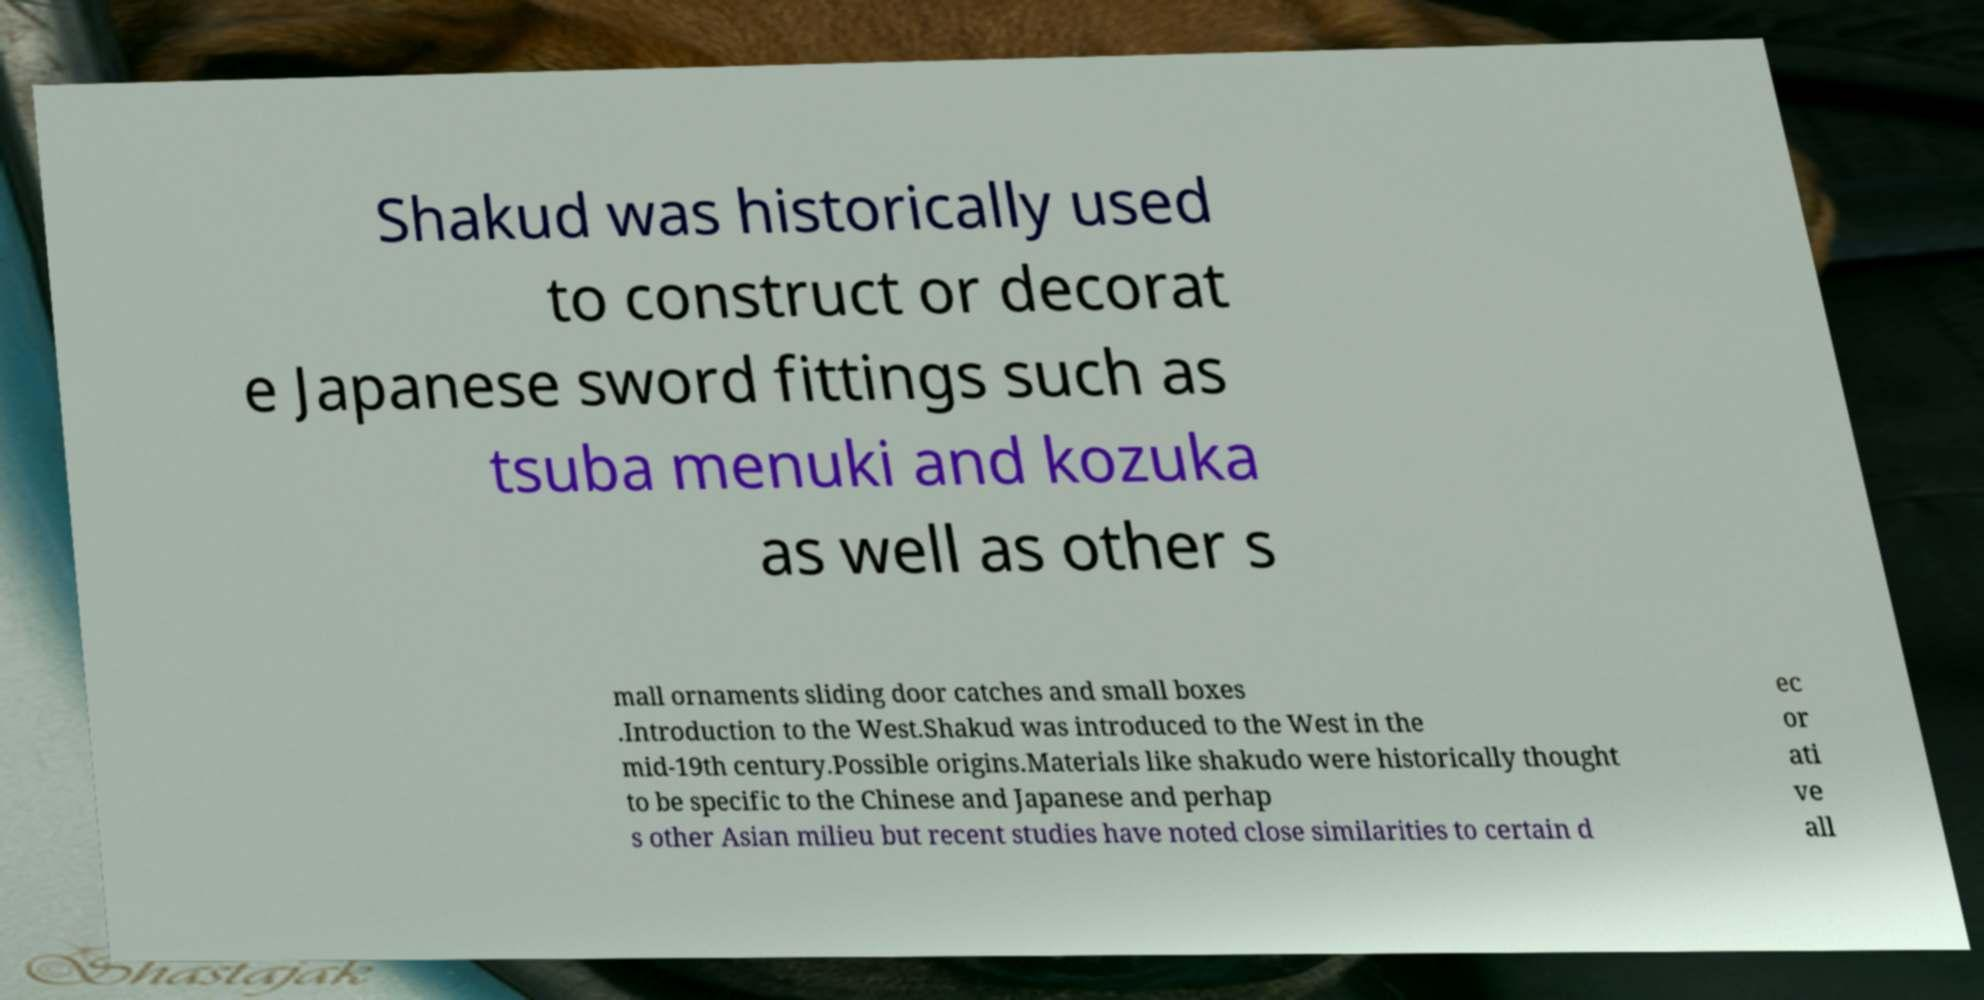Please read and relay the text visible in this image. What does it say? Shakud was historically used to construct or decorat e Japanese sword fittings such as tsuba menuki and kozuka as well as other s mall ornaments sliding door catches and small boxes .Introduction to the West.Shakud was introduced to the West in the mid-19th century.Possible origins.Materials like shakudo were historically thought to be specific to the Chinese and Japanese and perhap s other Asian milieu but recent studies have noted close similarities to certain d ec or ati ve all 